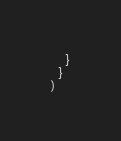Convert code to text. <code><loc_0><loc_0><loc_500><loc_500><_Ruby_>    }
  }
)
</code> 